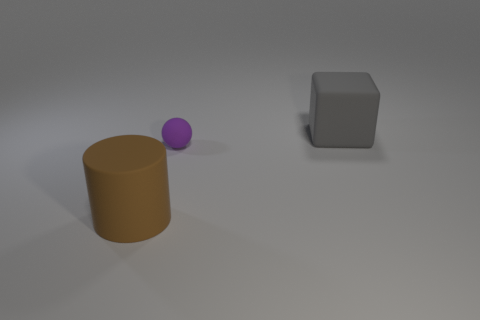How many things are either things that are on the right side of the rubber cylinder or big gray cubes?
Keep it short and to the point. 2. There is a large rubber object that is in front of the big matte thing to the right of the small purple object; how many big gray matte blocks are to the left of it?
Provide a short and direct response. 0. Is there anything else that is the same size as the rubber ball?
Offer a terse response. No. There is a big thing to the left of the big matte thing that is behind the big thing in front of the block; what is its shape?
Keep it short and to the point. Cylinder. What number of other objects are there of the same color as the large cylinder?
Provide a succinct answer. 0. The large rubber thing that is in front of the big thing to the right of the small rubber ball is what shape?
Provide a succinct answer. Cylinder. There is a rubber ball; how many large brown objects are right of it?
Your answer should be very brief. 0. Are there any other big blocks that have the same material as the large gray block?
Your response must be concise. No. There is a gray cube that is the same size as the rubber cylinder; what is it made of?
Your answer should be very brief. Rubber. There is a matte object that is both to the left of the cube and on the right side of the large brown rubber object; what is its size?
Make the answer very short. Small. 